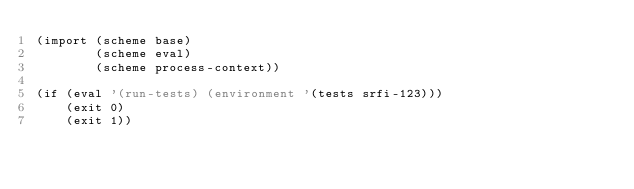Convert code to text. <code><loc_0><loc_0><loc_500><loc_500><_Scheme_>(import (scheme base)
        (scheme eval)
        (scheme process-context))

(if (eval '(run-tests) (environment '(tests srfi-123)))
    (exit 0)
    (exit 1))
</code> 